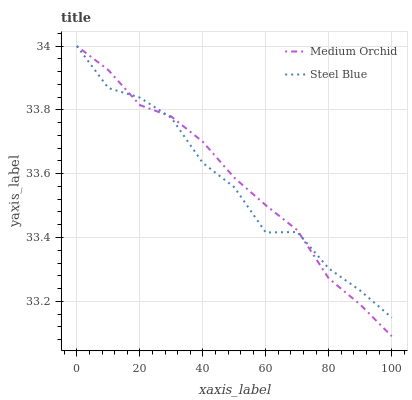Does Steel Blue have the minimum area under the curve?
Answer yes or no. Yes. Does Medium Orchid have the maximum area under the curve?
Answer yes or no. Yes. Does Steel Blue have the maximum area under the curve?
Answer yes or no. No. Is Medium Orchid the smoothest?
Answer yes or no. Yes. Is Steel Blue the roughest?
Answer yes or no. Yes. Is Steel Blue the smoothest?
Answer yes or no. No. Does Medium Orchid have the lowest value?
Answer yes or no. Yes. Does Steel Blue have the lowest value?
Answer yes or no. No. Does Steel Blue have the highest value?
Answer yes or no. Yes. Does Steel Blue intersect Medium Orchid?
Answer yes or no. Yes. Is Steel Blue less than Medium Orchid?
Answer yes or no. No. Is Steel Blue greater than Medium Orchid?
Answer yes or no. No. 